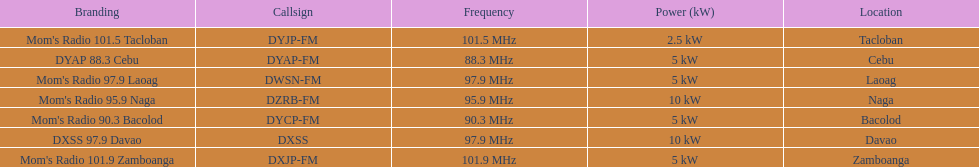Which stations use less than 10kw of power? Mom's Radio 97.9 Laoag, Mom's Radio 90.3 Bacolod, DYAP 88.3 Cebu, Mom's Radio 101.5 Tacloban, Mom's Radio 101.9 Zamboanga. Do any stations use less than 5kw of power? if so, which ones? Mom's Radio 101.5 Tacloban. 